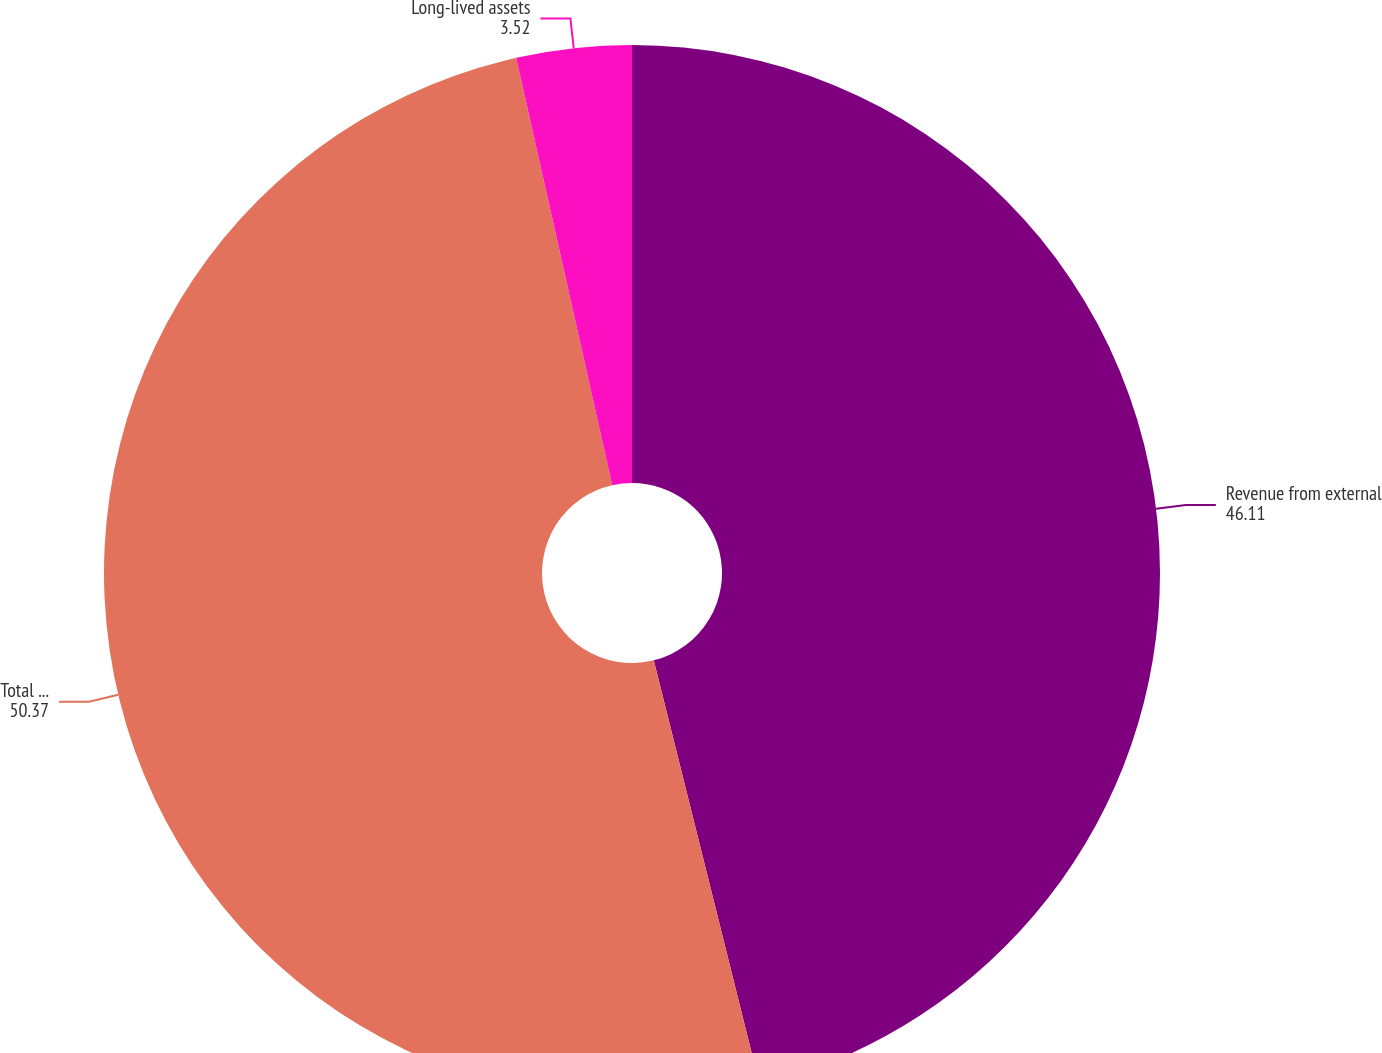Convert chart to OTSL. <chart><loc_0><loc_0><loc_500><loc_500><pie_chart><fcel>Revenue from external<fcel>Total operating revenues<fcel>Long-lived assets<nl><fcel>46.11%<fcel>50.37%<fcel>3.52%<nl></chart> 